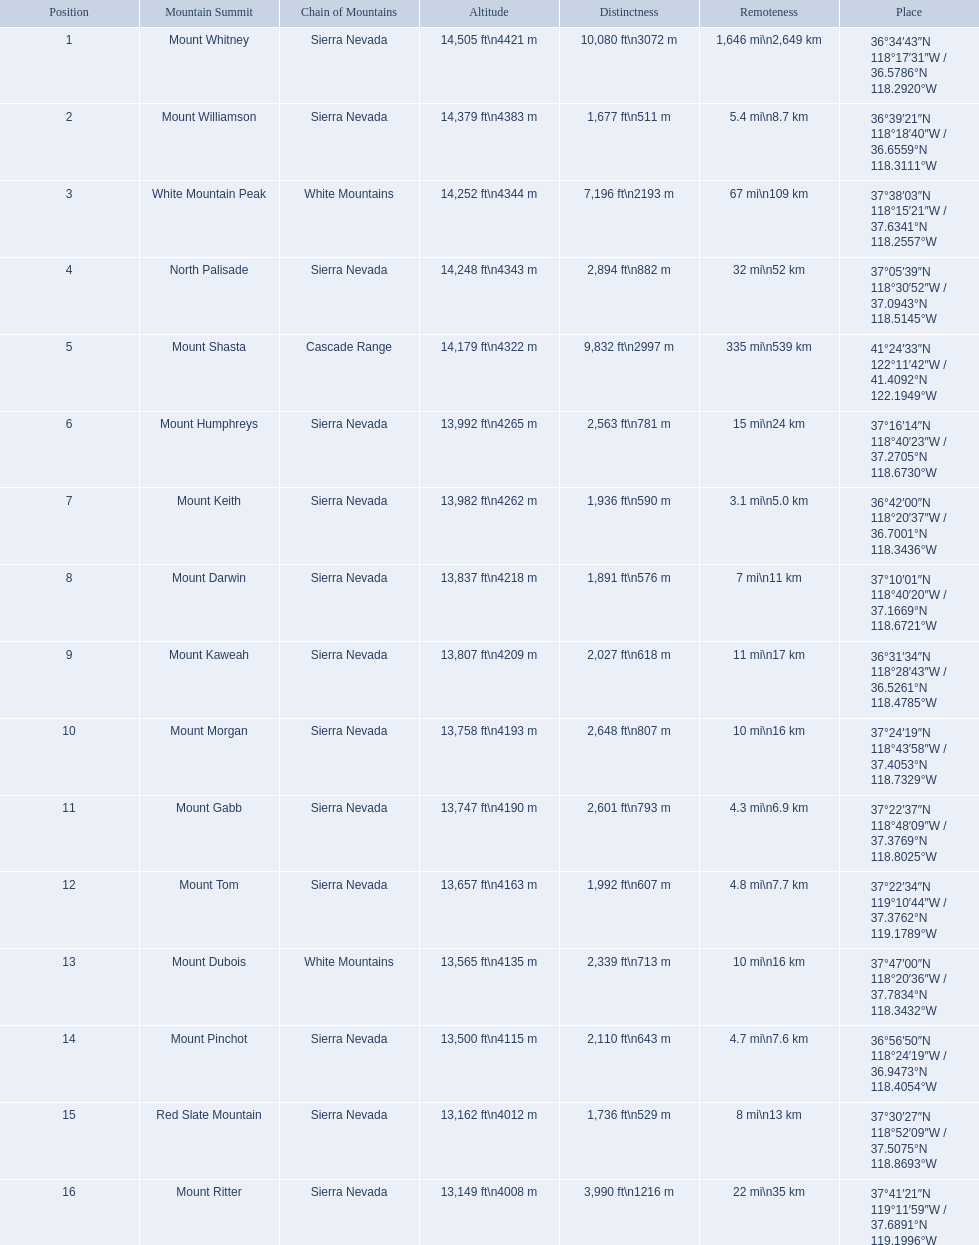Which mountain peaks are lower than 14,000 ft? Mount Humphreys, Mount Keith, Mount Darwin, Mount Kaweah, Mount Morgan, Mount Gabb, Mount Tom, Mount Dubois, Mount Pinchot, Red Slate Mountain, Mount Ritter. Are any of them below 13,500? if so, which ones? Red Slate Mountain, Mount Ritter. What's the lowest peak? 13,149 ft\n4008 m. Which one is that? Mount Ritter. 